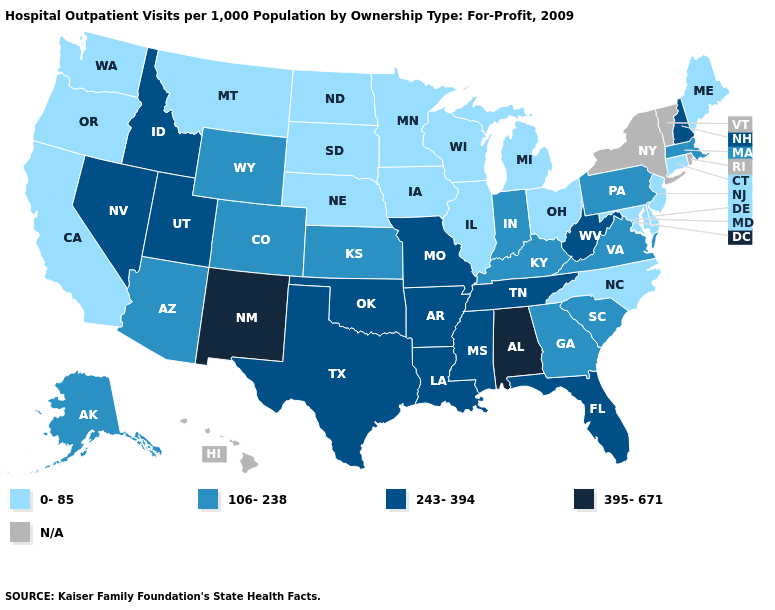Which states have the highest value in the USA?
Give a very brief answer. Alabama, New Mexico. Name the states that have a value in the range 0-85?
Keep it brief. California, Connecticut, Delaware, Illinois, Iowa, Maine, Maryland, Michigan, Minnesota, Montana, Nebraska, New Jersey, North Carolina, North Dakota, Ohio, Oregon, South Dakota, Washington, Wisconsin. Name the states that have a value in the range N/A?
Write a very short answer. Hawaii, New York, Rhode Island, Vermont. What is the highest value in the USA?
Keep it brief. 395-671. Does the first symbol in the legend represent the smallest category?
Concise answer only. Yes. What is the value of Alabama?
Keep it brief. 395-671. What is the value of Maine?
Keep it brief. 0-85. Does Maryland have the lowest value in the South?
Write a very short answer. Yes. Does New Mexico have the highest value in the West?
Be succinct. Yes. What is the value of Massachusetts?
Give a very brief answer. 106-238. Does Kentucky have the lowest value in the USA?
Write a very short answer. No. Name the states that have a value in the range N/A?
Keep it brief. Hawaii, New York, Rhode Island, Vermont. Among the states that border Virginia , which have the lowest value?
Keep it brief. Maryland, North Carolina. Does North Carolina have the lowest value in the South?
Give a very brief answer. Yes. Name the states that have a value in the range 106-238?
Give a very brief answer. Alaska, Arizona, Colorado, Georgia, Indiana, Kansas, Kentucky, Massachusetts, Pennsylvania, South Carolina, Virginia, Wyoming. 